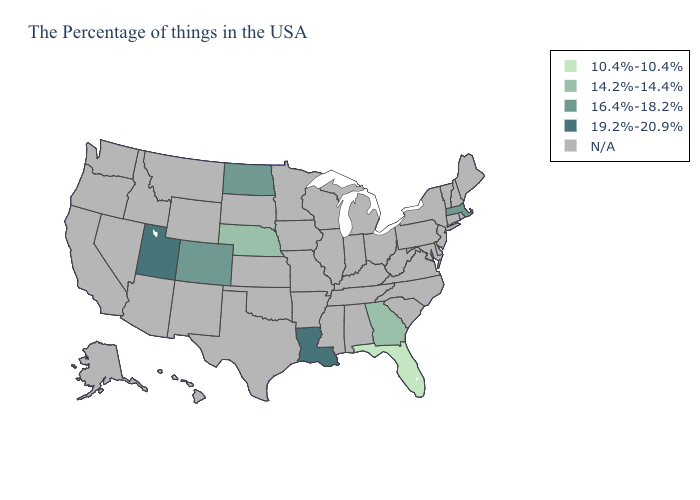What is the value of North Dakota?
Write a very short answer. 16.4%-18.2%. Which states have the highest value in the USA?
Concise answer only. Louisiana, Utah. Which states have the lowest value in the South?
Quick response, please. Florida. Which states have the highest value in the USA?
Be succinct. Louisiana, Utah. Name the states that have a value in the range N/A?
Keep it brief. Maine, Rhode Island, New Hampshire, Vermont, Connecticut, New York, New Jersey, Delaware, Maryland, Pennsylvania, Virginia, North Carolina, South Carolina, West Virginia, Ohio, Michigan, Kentucky, Indiana, Alabama, Tennessee, Wisconsin, Illinois, Mississippi, Missouri, Arkansas, Minnesota, Iowa, Kansas, Oklahoma, Texas, South Dakota, Wyoming, New Mexico, Montana, Arizona, Idaho, Nevada, California, Washington, Oregon, Alaska, Hawaii. What is the value of Nevada?
Concise answer only. N/A. Name the states that have a value in the range 16.4%-18.2%?
Concise answer only. Massachusetts, North Dakota, Colorado. What is the lowest value in the USA?
Write a very short answer. 10.4%-10.4%. What is the lowest value in the South?
Quick response, please. 10.4%-10.4%. Name the states that have a value in the range 14.2%-14.4%?
Write a very short answer. Georgia, Nebraska. Does Nebraska have the lowest value in the MidWest?
Short answer required. Yes. What is the value of Colorado?
Quick response, please. 16.4%-18.2%. 